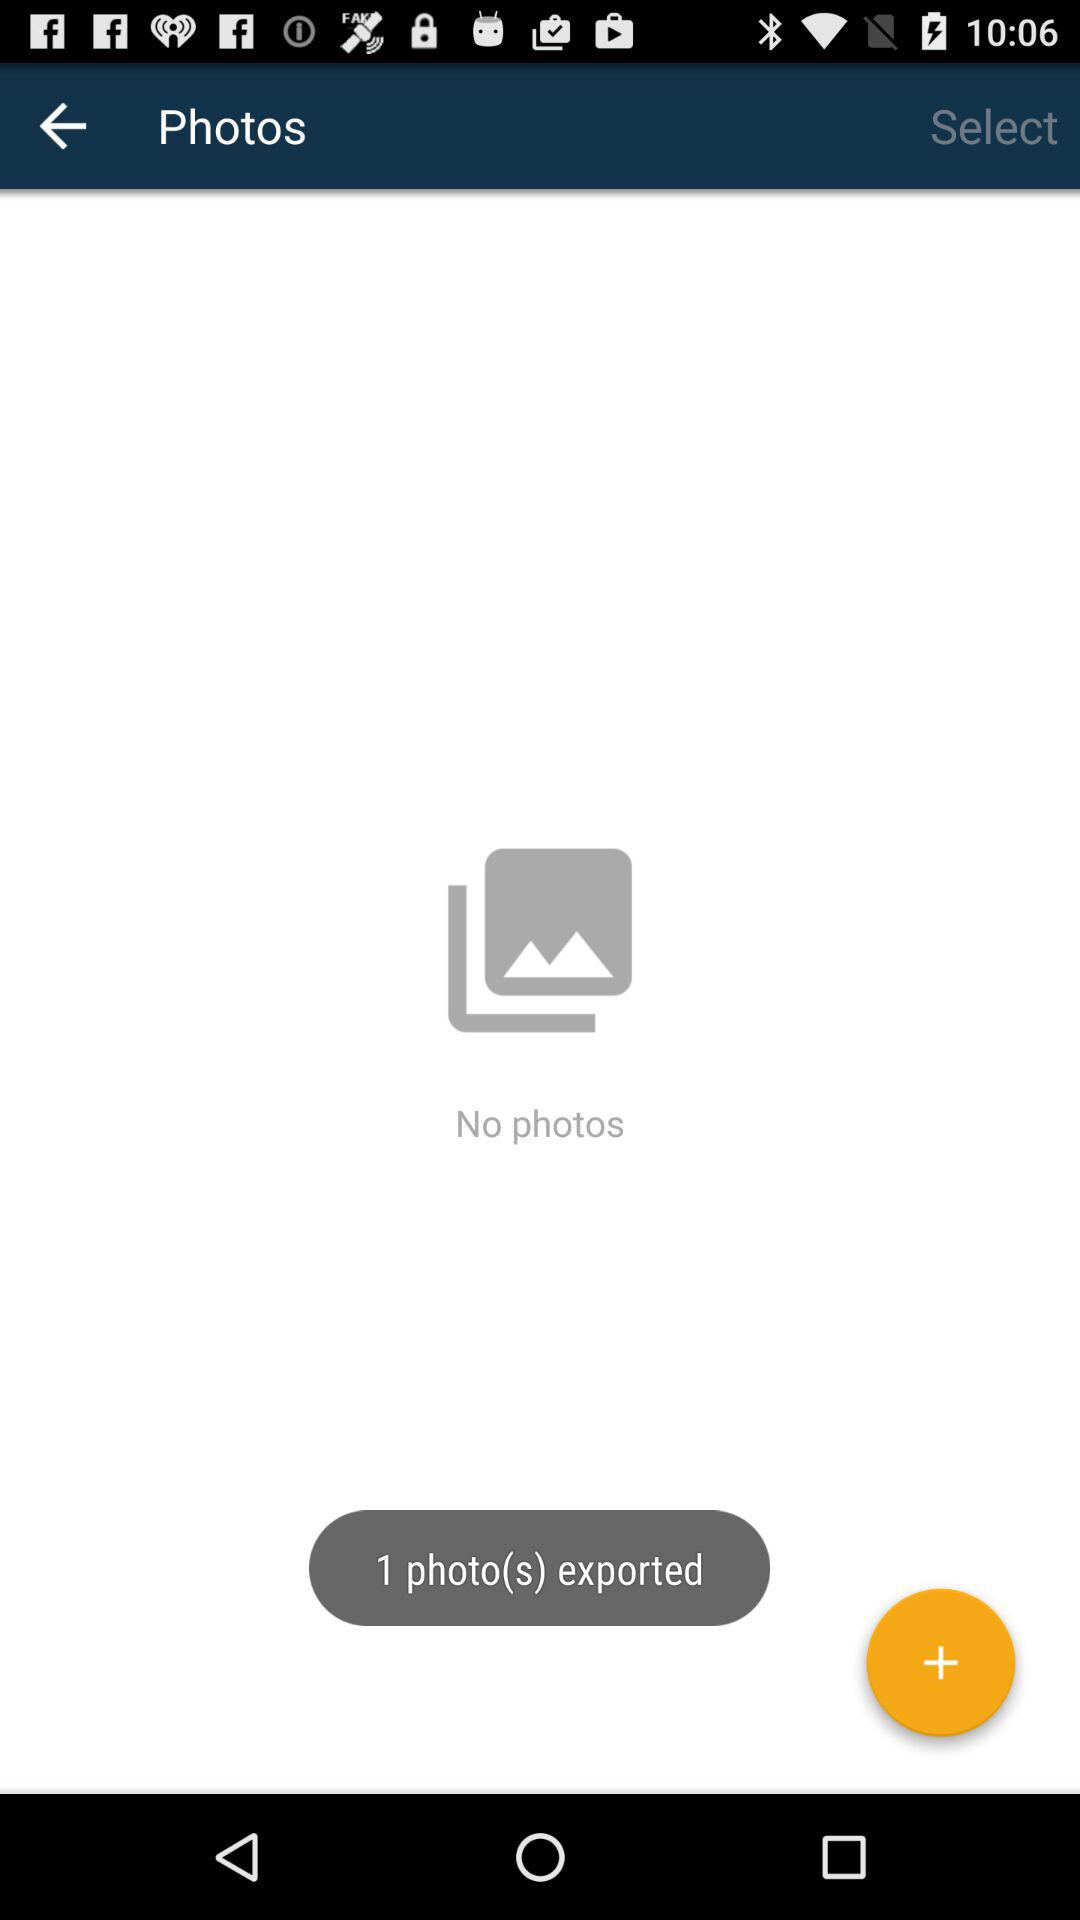How many photos are exported? There is 1 photo exported. 